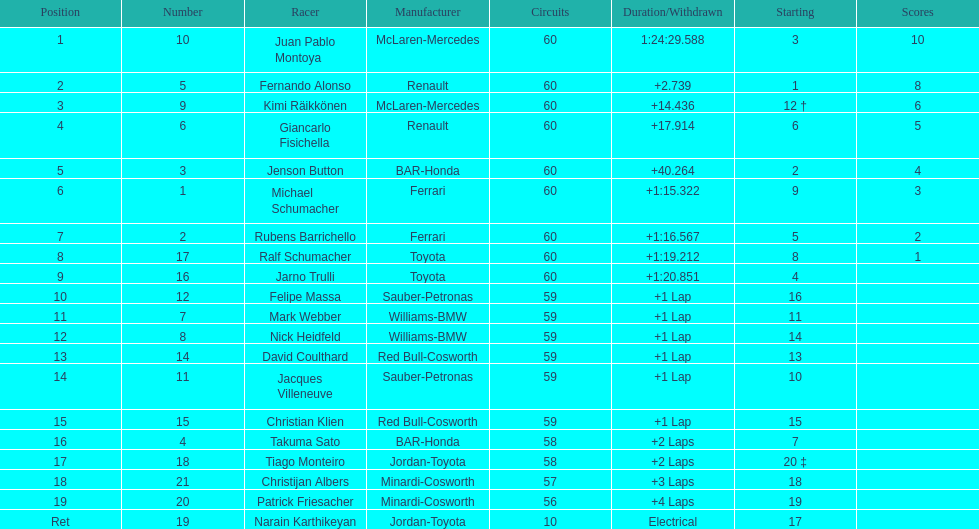What is the number of toyota's on the list? 4. 